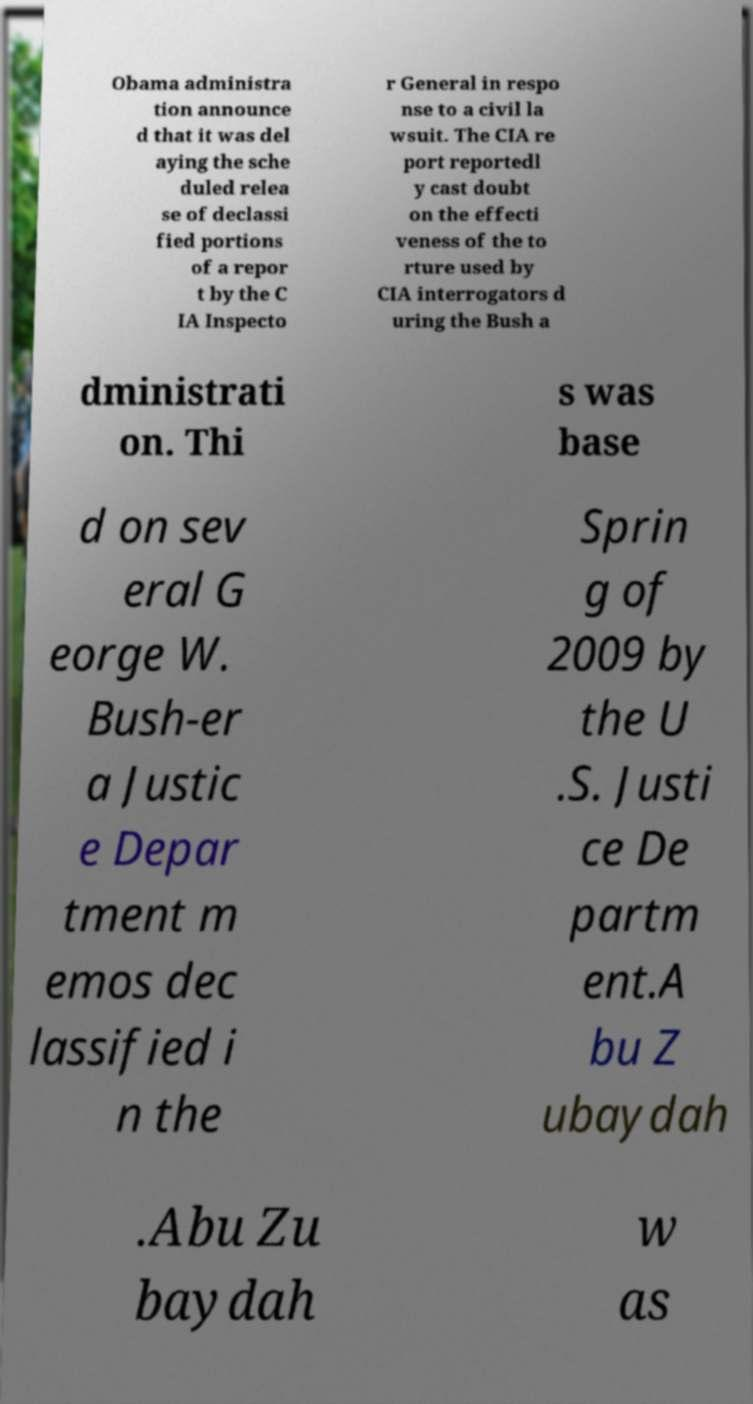For documentation purposes, I need the text within this image transcribed. Could you provide that? Obama administra tion announce d that it was del aying the sche duled relea se of declassi fied portions of a repor t by the C IA Inspecto r General in respo nse to a civil la wsuit. The CIA re port reportedl y cast doubt on the effecti veness of the to rture used by CIA interrogators d uring the Bush a dministrati on. Thi s was base d on sev eral G eorge W. Bush-er a Justic e Depar tment m emos dec lassified i n the Sprin g of 2009 by the U .S. Justi ce De partm ent.A bu Z ubaydah .Abu Zu baydah w as 